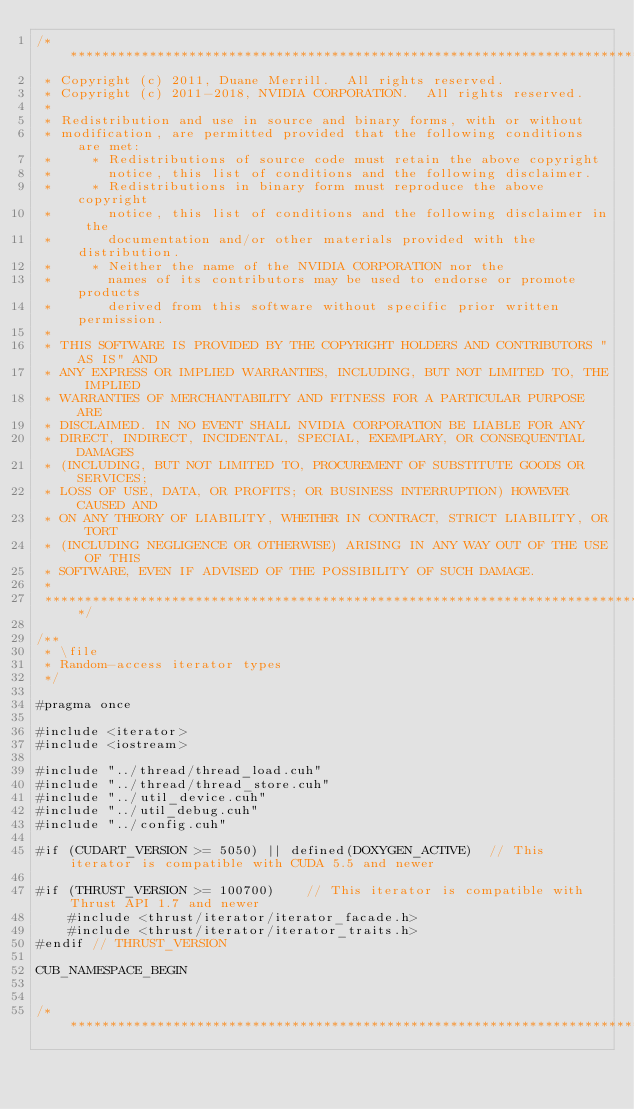Convert code to text. <code><loc_0><loc_0><loc_500><loc_500><_Cuda_>/******************************************************************************
 * Copyright (c) 2011, Duane Merrill.  All rights reserved.
 * Copyright (c) 2011-2018, NVIDIA CORPORATION.  All rights reserved.
 *
 * Redistribution and use in source and binary forms, with or without
 * modification, are permitted provided that the following conditions are met:
 *     * Redistributions of source code must retain the above copyright
 *       notice, this list of conditions and the following disclaimer.
 *     * Redistributions in binary form must reproduce the above copyright
 *       notice, this list of conditions and the following disclaimer in the
 *       documentation and/or other materials provided with the distribution.
 *     * Neither the name of the NVIDIA CORPORATION nor the
 *       names of its contributors may be used to endorse or promote products
 *       derived from this software without specific prior written permission.
 *
 * THIS SOFTWARE IS PROVIDED BY THE COPYRIGHT HOLDERS AND CONTRIBUTORS "AS IS" AND
 * ANY EXPRESS OR IMPLIED WARRANTIES, INCLUDING, BUT NOT LIMITED TO, THE IMPLIED
 * WARRANTIES OF MERCHANTABILITY AND FITNESS FOR A PARTICULAR PURPOSE ARE
 * DISCLAIMED. IN NO EVENT SHALL NVIDIA CORPORATION BE LIABLE FOR ANY
 * DIRECT, INDIRECT, INCIDENTAL, SPECIAL, EXEMPLARY, OR CONSEQUENTIAL DAMAGES
 * (INCLUDING, BUT NOT LIMITED TO, PROCUREMENT OF SUBSTITUTE GOODS OR SERVICES;
 * LOSS OF USE, DATA, OR PROFITS; OR BUSINESS INTERRUPTION) HOWEVER CAUSED AND
 * ON ANY THEORY OF LIABILITY, WHETHER IN CONTRACT, STRICT LIABILITY, OR TORT
 * (INCLUDING NEGLIGENCE OR OTHERWISE) ARISING IN ANY WAY OUT OF THE USE OF THIS
 * SOFTWARE, EVEN IF ADVISED OF THE POSSIBILITY OF SUCH DAMAGE.
 *
 ******************************************************************************/

/**
 * \file
 * Random-access iterator types
 */

#pragma once

#include <iterator>
#include <iostream>

#include "../thread/thread_load.cuh"
#include "../thread/thread_store.cuh"
#include "../util_device.cuh"
#include "../util_debug.cuh"
#include "../config.cuh"

#if (CUDART_VERSION >= 5050) || defined(DOXYGEN_ACTIVE)  // This iterator is compatible with CUDA 5.5 and newer

#if (THRUST_VERSION >= 100700)    // This iterator is compatible with Thrust API 1.7 and newer
    #include <thrust/iterator/iterator_facade.h>
    #include <thrust/iterator/iterator_traits.h>
#endif // THRUST_VERSION

CUB_NAMESPACE_BEGIN


/******************************************************************************</code> 